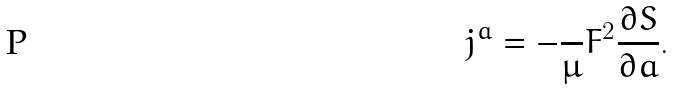<formula> <loc_0><loc_0><loc_500><loc_500>j ^ { a } = - \frac { } { \mu } F ^ { 2 } \frac { \partial S } { \partial a } .</formula> 